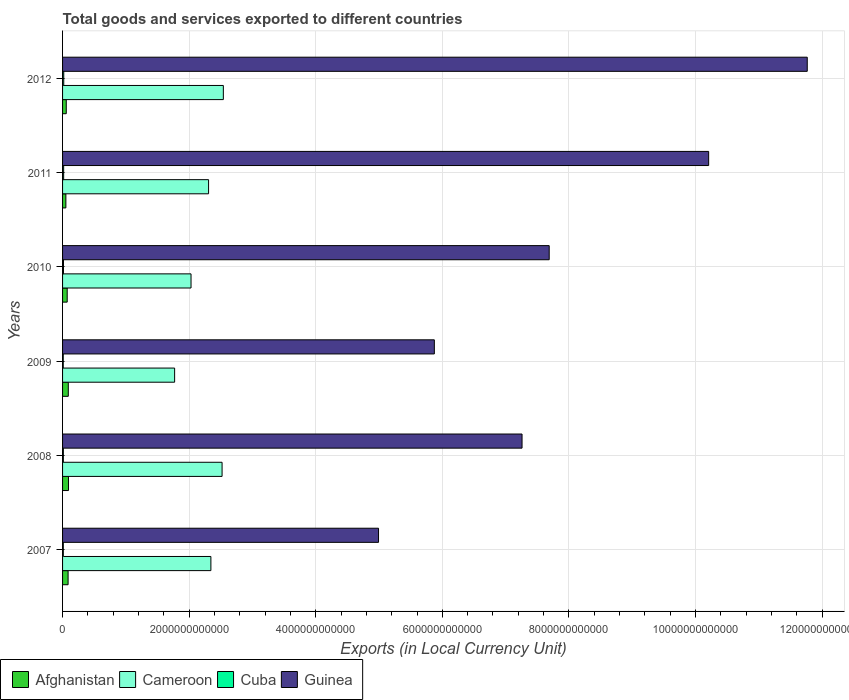How many different coloured bars are there?
Offer a terse response. 4. Are the number of bars per tick equal to the number of legend labels?
Make the answer very short. Yes. How many bars are there on the 1st tick from the bottom?
Your response must be concise. 4. In how many cases, is the number of bars for a given year not equal to the number of legend labels?
Your answer should be compact. 0. What is the Amount of goods and services exports in Cameroon in 2008?
Make the answer very short. 2.52e+12. Across all years, what is the maximum Amount of goods and services exports in Cameroon?
Give a very brief answer. 2.54e+12. Across all years, what is the minimum Amount of goods and services exports in Guinea?
Provide a succinct answer. 4.99e+12. What is the total Amount of goods and services exports in Cuba in the graph?
Ensure brevity in your answer.  8.58e+1. What is the difference between the Amount of goods and services exports in Afghanistan in 2007 and that in 2009?
Your answer should be compact. -3.06e+09. What is the difference between the Amount of goods and services exports in Guinea in 2011 and the Amount of goods and services exports in Afghanistan in 2007?
Provide a short and direct response. 1.01e+13. What is the average Amount of goods and services exports in Cuba per year?
Provide a succinct answer. 1.43e+1. In the year 2011, what is the difference between the Amount of goods and services exports in Cuba and Amount of goods and services exports in Cameroon?
Keep it short and to the point. -2.29e+12. What is the ratio of the Amount of goods and services exports in Afghanistan in 2007 to that in 2008?
Your response must be concise. 0.94. Is the Amount of goods and services exports in Cameroon in 2010 less than that in 2011?
Give a very brief answer. Yes. Is the difference between the Amount of goods and services exports in Cuba in 2010 and 2012 greater than the difference between the Amount of goods and services exports in Cameroon in 2010 and 2012?
Give a very brief answer. Yes. What is the difference between the highest and the second highest Amount of goods and services exports in Cameroon?
Provide a short and direct response. 2.00e+1. What is the difference between the highest and the lowest Amount of goods and services exports in Cameroon?
Offer a very short reply. 7.70e+11. Is it the case that in every year, the sum of the Amount of goods and services exports in Afghanistan and Amount of goods and services exports in Cameroon is greater than the sum of Amount of goods and services exports in Guinea and Amount of goods and services exports in Cuba?
Ensure brevity in your answer.  No. What does the 1st bar from the top in 2007 represents?
Offer a terse response. Guinea. What does the 4th bar from the bottom in 2011 represents?
Your answer should be compact. Guinea. Are all the bars in the graph horizontal?
Give a very brief answer. Yes. How many years are there in the graph?
Give a very brief answer. 6. What is the difference between two consecutive major ticks on the X-axis?
Provide a succinct answer. 2.00e+12. Does the graph contain any zero values?
Your response must be concise. No. Does the graph contain grids?
Ensure brevity in your answer.  Yes. Where does the legend appear in the graph?
Provide a succinct answer. Bottom left. How many legend labels are there?
Make the answer very short. 4. How are the legend labels stacked?
Provide a succinct answer. Horizontal. What is the title of the graph?
Make the answer very short. Total goods and services exported to different countries. What is the label or title of the X-axis?
Your answer should be very brief. Exports (in Local Currency Unit). What is the Exports (in Local Currency Unit) of Afghanistan in 2007?
Offer a very short reply. 8.74e+1. What is the Exports (in Local Currency Unit) in Cameroon in 2007?
Offer a very short reply. 2.34e+12. What is the Exports (in Local Currency Unit) in Cuba in 2007?
Provide a short and direct response. 1.19e+1. What is the Exports (in Local Currency Unit) of Guinea in 2007?
Ensure brevity in your answer.  4.99e+12. What is the Exports (in Local Currency Unit) in Afghanistan in 2008?
Give a very brief answer. 9.34e+1. What is the Exports (in Local Currency Unit) of Cameroon in 2008?
Give a very brief answer. 2.52e+12. What is the Exports (in Local Currency Unit) in Cuba in 2008?
Give a very brief answer. 1.25e+1. What is the Exports (in Local Currency Unit) of Guinea in 2008?
Keep it short and to the point. 7.26e+12. What is the Exports (in Local Currency Unit) in Afghanistan in 2009?
Make the answer very short. 9.05e+1. What is the Exports (in Local Currency Unit) of Cameroon in 2009?
Offer a very short reply. 1.77e+12. What is the Exports (in Local Currency Unit) of Cuba in 2009?
Make the answer very short. 1.08e+1. What is the Exports (in Local Currency Unit) in Guinea in 2009?
Your answer should be compact. 5.87e+12. What is the Exports (in Local Currency Unit) in Afghanistan in 2010?
Your response must be concise. 7.32e+1. What is the Exports (in Local Currency Unit) of Cameroon in 2010?
Offer a terse response. 2.03e+12. What is the Exports (in Local Currency Unit) of Cuba in 2010?
Give a very brief answer. 1.45e+1. What is the Exports (in Local Currency Unit) of Guinea in 2010?
Provide a short and direct response. 7.69e+12. What is the Exports (in Local Currency Unit) of Afghanistan in 2011?
Offer a terse response. 5.23e+1. What is the Exports (in Local Currency Unit) in Cameroon in 2011?
Make the answer very short. 2.31e+12. What is the Exports (in Local Currency Unit) in Cuba in 2011?
Provide a succinct answer. 1.73e+1. What is the Exports (in Local Currency Unit) of Guinea in 2011?
Keep it short and to the point. 1.02e+13. What is the Exports (in Local Currency Unit) in Afghanistan in 2012?
Make the answer very short. 5.86e+1. What is the Exports (in Local Currency Unit) in Cameroon in 2012?
Provide a short and direct response. 2.54e+12. What is the Exports (in Local Currency Unit) in Cuba in 2012?
Keep it short and to the point. 1.87e+1. What is the Exports (in Local Currency Unit) of Guinea in 2012?
Your response must be concise. 1.18e+13. Across all years, what is the maximum Exports (in Local Currency Unit) in Afghanistan?
Keep it short and to the point. 9.34e+1. Across all years, what is the maximum Exports (in Local Currency Unit) of Cameroon?
Give a very brief answer. 2.54e+12. Across all years, what is the maximum Exports (in Local Currency Unit) in Cuba?
Ensure brevity in your answer.  1.87e+1. Across all years, what is the maximum Exports (in Local Currency Unit) in Guinea?
Provide a short and direct response. 1.18e+13. Across all years, what is the minimum Exports (in Local Currency Unit) in Afghanistan?
Your answer should be very brief. 5.23e+1. Across all years, what is the minimum Exports (in Local Currency Unit) of Cameroon?
Keep it short and to the point. 1.77e+12. Across all years, what is the minimum Exports (in Local Currency Unit) in Cuba?
Give a very brief answer. 1.08e+1. Across all years, what is the minimum Exports (in Local Currency Unit) of Guinea?
Offer a terse response. 4.99e+12. What is the total Exports (in Local Currency Unit) of Afghanistan in the graph?
Offer a very short reply. 4.55e+11. What is the total Exports (in Local Currency Unit) in Cameroon in the graph?
Your response must be concise. 1.35e+13. What is the total Exports (in Local Currency Unit) of Cuba in the graph?
Ensure brevity in your answer.  8.58e+1. What is the total Exports (in Local Currency Unit) in Guinea in the graph?
Keep it short and to the point. 4.78e+13. What is the difference between the Exports (in Local Currency Unit) of Afghanistan in 2007 and that in 2008?
Your answer should be very brief. -6.01e+09. What is the difference between the Exports (in Local Currency Unit) of Cameroon in 2007 and that in 2008?
Your response must be concise. -1.77e+11. What is the difference between the Exports (in Local Currency Unit) in Cuba in 2007 and that in 2008?
Make the answer very short. -5.88e+08. What is the difference between the Exports (in Local Currency Unit) in Guinea in 2007 and that in 2008?
Your answer should be compact. -2.27e+12. What is the difference between the Exports (in Local Currency Unit) of Afghanistan in 2007 and that in 2009?
Your answer should be very brief. -3.06e+09. What is the difference between the Exports (in Local Currency Unit) in Cameroon in 2007 and that in 2009?
Provide a succinct answer. 5.73e+11. What is the difference between the Exports (in Local Currency Unit) of Cuba in 2007 and that in 2009?
Offer a very short reply. 1.08e+09. What is the difference between the Exports (in Local Currency Unit) of Guinea in 2007 and that in 2009?
Offer a very short reply. -8.82e+11. What is the difference between the Exports (in Local Currency Unit) of Afghanistan in 2007 and that in 2010?
Give a very brief answer. 1.42e+1. What is the difference between the Exports (in Local Currency Unit) in Cameroon in 2007 and that in 2010?
Ensure brevity in your answer.  3.14e+11. What is the difference between the Exports (in Local Currency Unit) in Cuba in 2007 and that in 2010?
Offer a terse response. -2.60e+09. What is the difference between the Exports (in Local Currency Unit) in Guinea in 2007 and that in 2010?
Offer a very short reply. -2.70e+12. What is the difference between the Exports (in Local Currency Unit) in Afghanistan in 2007 and that in 2011?
Your response must be concise. 3.51e+1. What is the difference between the Exports (in Local Currency Unit) of Cameroon in 2007 and that in 2011?
Your answer should be compact. 3.65e+1. What is the difference between the Exports (in Local Currency Unit) of Cuba in 2007 and that in 2011?
Provide a short and direct response. -5.40e+09. What is the difference between the Exports (in Local Currency Unit) of Guinea in 2007 and that in 2011?
Offer a very short reply. -5.22e+12. What is the difference between the Exports (in Local Currency Unit) in Afghanistan in 2007 and that in 2012?
Make the answer very short. 2.89e+1. What is the difference between the Exports (in Local Currency Unit) of Cameroon in 2007 and that in 2012?
Your response must be concise. -1.97e+11. What is the difference between the Exports (in Local Currency Unit) of Cuba in 2007 and that in 2012?
Your answer should be very brief. -6.74e+09. What is the difference between the Exports (in Local Currency Unit) in Guinea in 2007 and that in 2012?
Offer a very short reply. -6.77e+12. What is the difference between the Exports (in Local Currency Unit) of Afghanistan in 2008 and that in 2009?
Offer a very short reply. 2.95e+09. What is the difference between the Exports (in Local Currency Unit) of Cameroon in 2008 and that in 2009?
Offer a terse response. 7.50e+11. What is the difference between the Exports (in Local Currency Unit) in Cuba in 2008 and that in 2009?
Ensure brevity in your answer.  1.67e+09. What is the difference between the Exports (in Local Currency Unit) of Guinea in 2008 and that in 2009?
Keep it short and to the point. 1.39e+12. What is the difference between the Exports (in Local Currency Unit) of Afghanistan in 2008 and that in 2010?
Provide a succinct answer. 2.03e+1. What is the difference between the Exports (in Local Currency Unit) of Cameroon in 2008 and that in 2010?
Offer a terse response. 4.91e+11. What is the difference between the Exports (in Local Currency Unit) of Cuba in 2008 and that in 2010?
Provide a succinct answer. -2.01e+09. What is the difference between the Exports (in Local Currency Unit) in Guinea in 2008 and that in 2010?
Ensure brevity in your answer.  -4.29e+11. What is the difference between the Exports (in Local Currency Unit) of Afghanistan in 2008 and that in 2011?
Make the answer very short. 4.11e+1. What is the difference between the Exports (in Local Currency Unit) in Cameroon in 2008 and that in 2011?
Keep it short and to the point. 2.13e+11. What is the difference between the Exports (in Local Currency Unit) in Cuba in 2008 and that in 2011?
Make the answer very short. -4.81e+09. What is the difference between the Exports (in Local Currency Unit) of Guinea in 2008 and that in 2011?
Your answer should be very brief. -2.95e+12. What is the difference between the Exports (in Local Currency Unit) of Afghanistan in 2008 and that in 2012?
Your response must be concise. 3.49e+1. What is the difference between the Exports (in Local Currency Unit) in Cameroon in 2008 and that in 2012?
Ensure brevity in your answer.  -2.00e+1. What is the difference between the Exports (in Local Currency Unit) in Cuba in 2008 and that in 2012?
Provide a succinct answer. -6.15e+09. What is the difference between the Exports (in Local Currency Unit) in Guinea in 2008 and that in 2012?
Your answer should be compact. -4.51e+12. What is the difference between the Exports (in Local Currency Unit) in Afghanistan in 2009 and that in 2010?
Provide a short and direct response. 1.73e+1. What is the difference between the Exports (in Local Currency Unit) of Cameroon in 2009 and that in 2010?
Ensure brevity in your answer.  -2.59e+11. What is the difference between the Exports (in Local Currency Unit) in Cuba in 2009 and that in 2010?
Offer a very short reply. -3.68e+09. What is the difference between the Exports (in Local Currency Unit) in Guinea in 2009 and that in 2010?
Offer a terse response. -1.81e+12. What is the difference between the Exports (in Local Currency Unit) of Afghanistan in 2009 and that in 2011?
Your answer should be compact. 3.82e+1. What is the difference between the Exports (in Local Currency Unit) in Cameroon in 2009 and that in 2011?
Give a very brief answer. -5.36e+11. What is the difference between the Exports (in Local Currency Unit) of Cuba in 2009 and that in 2011?
Keep it short and to the point. -6.48e+09. What is the difference between the Exports (in Local Currency Unit) in Guinea in 2009 and that in 2011?
Offer a very short reply. -4.33e+12. What is the difference between the Exports (in Local Currency Unit) of Afghanistan in 2009 and that in 2012?
Provide a succinct answer. 3.19e+1. What is the difference between the Exports (in Local Currency Unit) in Cameroon in 2009 and that in 2012?
Keep it short and to the point. -7.70e+11. What is the difference between the Exports (in Local Currency Unit) in Cuba in 2009 and that in 2012?
Your answer should be very brief. -7.82e+09. What is the difference between the Exports (in Local Currency Unit) in Guinea in 2009 and that in 2012?
Ensure brevity in your answer.  -5.89e+12. What is the difference between the Exports (in Local Currency Unit) in Afghanistan in 2010 and that in 2011?
Provide a succinct answer. 2.09e+1. What is the difference between the Exports (in Local Currency Unit) in Cameroon in 2010 and that in 2011?
Give a very brief answer. -2.77e+11. What is the difference between the Exports (in Local Currency Unit) in Cuba in 2010 and that in 2011?
Your answer should be very brief. -2.80e+09. What is the difference between the Exports (in Local Currency Unit) in Guinea in 2010 and that in 2011?
Your response must be concise. -2.52e+12. What is the difference between the Exports (in Local Currency Unit) of Afghanistan in 2010 and that in 2012?
Make the answer very short. 1.46e+1. What is the difference between the Exports (in Local Currency Unit) in Cameroon in 2010 and that in 2012?
Make the answer very short. -5.11e+11. What is the difference between the Exports (in Local Currency Unit) in Cuba in 2010 and that in 2012?
Offer a very short reply. -4.14e+09. What is the difference between the Exports (in Local Currency Unit) in Guinea in 2010 and that in 2012?
Ensure brevity in your answer.  -4.08e+12. What is the difference between the Exports (in Local Currency Unit) in Afghanistan in 2011 and that in 2012?
Your response must be concise. -6.25e+09. What is the difference between the Exports (in Local Currency Unit) in Cameroon in 2011 and that in 2012?
Your answer should be very brief. -2.33e+11. What is the difference between the Exports (in Local Currency Unit) of Cuba in 2011 and that in 2012?
Make the answer very short. -1.34e+09. What is the difference between the Exports (in Local Currency Unit) of Guinea in 2011 and that in 2012?
Keep it short and to the point. -1.56e+12. What is the difference between the Exports (in Local Currency Unit) of Afghanistan in 2007 and the Exports (in Local Currency Unit) of Cameroon in 2008?
Make the answer very short. -2.43e+12. What is the difference between the Exports (in Local Currency Unit) in Afghanistan in 2007 and the Exports (in Local Currency Unit) in Cuba in 2008?
Offer a very short reply. 7.49e+1. What is the difference between the Exports (in Local Currency Unit) in Afghanistan in 2007 and the Exports (in Local Currency Unit) in Guinea in 2008?
Make the answer very short. -7.17e+12. What is the difference between the Exports (in Local Currency Unit) of Cameroon in 2007 and the Exports (in Local Currency Unit) of Cuba in 2008?
Offer a terse response. 2.33e+12. What is the difference between the Exports (in Local Currency Unit) in Cameroon in 2007 and the Exports (in Local Currency Unit) in Guinea in 2008?
Your answer should be compact. -4.92e+12. What is the difference between the Exports (in Local Currency Unit) of Cuba in 2007 and the Exports (in Local Currency Unit) of Guinea in 2008?
Your response must be concise. -7.25e+12. What is the difference between the Exports (in Local Currency Unit) in Afghanistan in 2007 and the Exports (in Local Currency Unit) in Cameroon in 2009?
Make the answer very short. -1.68e+12. What is the difference between the Exports (in Local Currency Unit) in Afghanistan in 2007 and the Exports (in Local Currency Unit) in Cuba in 2009?
Keep it short and to the point. 7.66e+1. What is the difference between the Exports (in Local Currency Unit) in Afghanistan in 2007 and the Exports (in Local Currency Unit) in Guinea in 2009?
Offer a terse response. -5.79e+12. What is the difference between the Exports (in Local Currency Unit) of Cameroon in 2007 and the Exports (in Local Currency Unit) of Cuba in 2009?
Your answer should be very brief. 2.33e+12. What is the difference between the Exports (in Local Currency Unit) in Cameroon in 2007 and the Exports (in Local Currency Unit) in Guinea in 2009?
Make the answer very short. -3.53e+12. What is the difference between the Exports (in Local Currency Unit) of Cuba in 2007 and the Exports (in Local Currency Unit) of Guinea in 2009?
Make the answer very short. -5.86e+12. What is the difference between the Exports (in Local Currency Unit) of Afghanistan in 2007 and the Exports (in Local Currency Unit) of Cameroon in 2010?
Give a very brief answer. -1.94e+12. What is the difference between the Exports (in Local Currency Unit) of Afghanistan in 2007 and the Exports (in Local Currency Unit) of Cuba in 2010?
Your answer should be very brief. 7.29e+1. What is the difference between the Exports (in Local Currency Unit) of Afghanistan in 2007 and the Exports (in Local Currency Unit) of Guinea in 2010?
Offer a very short reply. -7.60e+12. What is the difference between the Exports (in Local Currency Unit) of Cameroon in 2007 and the Exports (in Local Currency Unit) of Cuba in 2010?
Offer a very short reply. 2.33e+12. What is the difference between the Exports (in Local Currency Unit) in Cameroon in 2007 and the Exports (in Local Currency Unit) in Guinea in 2010?
Provide a succinct answer. -5.34e+12. What is the difference between the Exports (in Local Currency Unit) of Cuba in 2007 and the Exports (in Local Currency Unit) of Guinea in 2010?
Give a very brief answer. -7.68e+12. What is the difference between the Exports (in Local Currency Unit) of Afghanistan in 2007 and the Exports (in Local Currency Unit) of Cameroon in 2011?
Your answer should be compact. -2.22e+12. What is the difference between the Exports (in Local Currency Unit) in Afghanistan in 2007 and the Exports (in Local Currency Unit) in Cuba in 2011?
Your answer should be compact. 7.01e+1. What is the difference between the Exports (in Local Currency Unit) in Afghanistan in 2007 and the Exports (in Local Currency Unit) in Guinea in 2011?
Your answer should be compact. -1.01e+13. What is the difference between the Exports (in Local Currency Unit) in Cameroon in 2007 and the Exports (in Local Currency Unit) in Cuba in 2011?
Provide a short and direct response. 2.33e+12. What is the difference between the Exports (in Local Currency Unit) in Cameroon in 2007 and the Exports (in Local Currency Unit) in Guinea in 2011?
Offer a very short reply. -7.86e+12. What is the difference between the Exports (in Local Currency Unit) in Cuba in 2007 and the Exports (in Local Currency Unit) in Guinea in 2011?
Make the answer very short. -1.02e+13. What is the difference between the Exports (in Local Currency Unit) in Afghanistan in 2007 and the Exports (in Local Currency Unit) in Cameroon in 2012?
Provide a succinct answer. -2.45e+12. What is the difference between the Exports (in Local Currency Unit) of Afghanistan in 2007 and the Exports (in Local Currency Unit) of Cuba in 2012?
Provide a succinct answer. 6.87e+1. What is the difference between the Exports (in Local Currency Unit) of Afghanistan in 2007 and the Exports (in Local Currency Unit) of Guinea in 2012?
Your answer should be very brief. -1.17e+13. What is the difference between the Exports (in Local Currency Unit) of Cameroon in 2007 and the Exports (in Local Currency Unit) of Cuba in 2012?
Provide a succinct answer. 2.32e+12. What is the difference between the Exports (in Local Currency Unit) of Cameroon in 2007 and the Exports (in Local Currency Unit) of Guinea in 2012?
Your response must be concise. -9.42e+12. What is the difference between the Exports (in Local Currency Unit) of Cuba in 2007 and the Exports (in Local Currency Unit) of Guinea in 2012?
Your response must be concise. -1.18e+13. What is the difference between the Exports (in Local Currency Unit) in Afghanistan in 2008 and the Exports (in Local Currency Unit) in Cameroon in 2009?
Give a very brief answer. -1.68e+12. What is the difference between the Exports (in Local Currency Unit) in Afghanistan in 2008 and the Exports (in Local Currency Unit) in Cuba in 2009?
Keep it short and to the point. 8.26e+1. What is the difference between the Exports (in Local Currency Unit) in Afghanistan in 2008 and the Exports (in Local Currency Unit) in Guinea in 2009?
Make the answer very short. -5.78e+12. What is the difference between the Exports (in Local Currency Unit) of Cameroon in 2008 and the Exports (in Local Currency Unit) of Cuba in 2009?
Your answer should be compact. 2.51e+12. What is the difference between the Exports (in Local Currency Unit) of Cameroon in 2008 and the Exports (in Local Currency Unit) of Guinea in 2009?
Keep it short and to the point. -3.35e+12. What is the difference between the Exports (in Local Currency Unit) of Cuba in 2008 and the Exports (in Local Currency Unit) of Guinea in 2009?
Give a very brief answer. -5.86e+12. What is the difference between the Exports (in Local Currency Unit) in Afghanistan in 2008 and the Exports (in Local Currency Unit) in Cameroon in 2010?
Ensure brevity in your answer.  -1.94e+12. What is the difference between the Exports (in Local Currency Unit) in Afghanistan in 2008 and the Exports (in Local Currency Unit) in Cuba in 2010?
Your response must be concise. 7.89e+1. What is the difference between the Exports (in Local Currency Unit) in Afghanistan in 2008 and the Exports (in Local Currency Unit) in Guinea in 2010?
Your answer should be very brief. -7.59e+12. What is the difference between the Exports (in Local Currency Unit) in Cameroon in 2008 and the Exports (in Local Currency Unit) in Cuba in 2010?
Give a very brief answer. 2.51e+12. What is the difference between the Exports (in Local Currency Unit) of Cameroon in 2008 and the Exports (in Local Currency Unit) of Guinea in 2010?
Provide a short and direct response. -5.17e+12. What is the difference between the Exports (in Local Currency Unit) in Cuba in 2008 and the Exports (in Local Currency Unit) in Guinea in 2010?
Your answer should be compact. -7.68e+12. What is the difference between the Exports (in Local Currency Unit) of Afghanistan in 2008 and the Exports (in Local Currency Unit) of Cameroon in 2011?
Make the answer very short. -2.21e+12. What is the difference between the Exports (in Local Currency Unit) in Afghanistan in 2008 and the Exports (in Local Currency Unit) in Cuba in 2011?
Make the answer very short. 7.61e+1. What is the difference between the Exports (in Local Currency Unit) in Afghanistan in 2008 and the Exports (in Local Currency Unit) in Guinea in 2011?
Ensure brevity in your answer.  -1.01e+13. What is the difference between the Exports (in Local Currency Unit) in Cameroon in 2008 and the Exports (in Local Currency Unit) in Cuba in 2011?
Ensure brevity in your answer.  2.50e+12. What is the difference between the Exports (in Local Currency Unit) of Cameroon in 2008 and the Exports (in Local Currency Unit) of Guinea in 2011?
Provide a succinct answer. -7.69e+12. What is the difference between the Exports (in Local Currency Unit) of Cuba in 2008 and the Exports (in Local Currency Unit) of Guinea in 2011?
Your response must be concise. -1.02e+13. What is the difference between the Exports (in Local Currency Unit) in Afghanistan in 2008 and the Exports (in Local Currency Unit) in Cameroon in 2012?
Offer a terse response. -2.45e+12. What is the difference between the Exports (in Local Currency Unit) in Afghanistan in 2008 and the Exports (in Local Currency Unit) in Cuba in 2012?
Offer a very short reply. 7.48e+1. What is the difference between the Exports (in Local Currency Unit) of Afghanistan in 2008 and the Exports (in Local Currency Unit) of Guinea in 2012?
Provide a short and direct response. -1.17e+13. What is the difference between the Exports (in Local Currency Unit) of Cameroon in 2008 and the Exports (in Local Currency Unit) of Cuba in 2012?
Make the answer very short. 2.50e+12. What is the difference between the Exports (in Local Currency Unit) of Cameroon in 2008 and the Exports (in Local Currency Unit) of Guinea in 2012?
Your answer should be very brief. -9.24e+12. What is the difference between the Exports (in Local Currency Unit) in Cuba in 2008 and the Exports (in Local Currency Unit) in Guinea in 2012?
Give a very brief answer. -1.18e+13. What is the difference between the Exports (in Local Currency Unit) in Afghanistan in 2009 and the Exports (in Local Currency Unit) in Cameroon in 2010?
Your answer should be compact. -1.94e+12. What is the difference between the Exports (in Local Currency Unit) of Afghanistan in 2009 and the Exports (in Local Currency Unit) of Cuba in 2010?
Your answer should be compact. 7.59e+1. What is the difference between the Exports (in Local Currency Unit) in Afghanistan in 2009 and the Exports (in Local Currency Unit) in Guinea in 2010?
Provide a succinct answer. -7.60e+12. What is the difference between the Exports (in Local Currency Unit) of Cameroon in 2009 and the Exports (in Local Currency Unit) of Cuba in 2010?
Provide a short and direct response. 1.76e+12. What is the difference between the Exports (in Local Currency Unit) of Cameroon in 2009 and the Exports (in Local Currency Unit) of Guinea in 2010?
Make the answer very short. -5.92e+12. What is the difference between the Exports (in Local Currency Unit) of Cuba in 2009 and the Exports (in Local Currency Unit) of Guinea in 2010?
Offer a terse response. -7.68e+12. What is the difference between the Exports (in Local Currency Unit) in Afghanistan in 2009 and the Exports (in Local Currency Unit) in Cameroon in 2011?
Give a very brief answer. -2.22e+12. What is the difference between the Exports (in Local Currency Unit) in Afghanistan in 2009 and the Exports (in Local Currency Unit) in Cuba in 2011?
Ensure brevity in your answer.  7.31e+1. What is the difference between the Exports (in Local Currency Unit) in Afghanistan in 2009 and the Exports (in Local Currency Unit) in Guinea in 2011?
Give a very brief answer. -1.01e+13. What is the difference between the Exports (in Local Currency Unit) in Cameroon in 2009 and the Exports (in Local Currency Unit) in Cuba in 2011?
Your answer should be compact. 1.75e+12. What is the difference between the Exports (in Local Currency Unit) of Cameroon in 2009 and the Exports (in Local Currency Unit) of Guinea in 2011?
Give a very brief answer. -8.44e+12. What is the difference between the Exports (in Local Currency Unit) of Cuba in 2009 and the Exports (in Local Currency Unit) of Guinea in 2011?
Your answer should be very brief. -1.02e+13. What is the difference between the Exports (in Local Currency Unit) of Afghanistan in 2009 and the Exports (in Local Currency Unit) of Cameroon in 2012?
Offer a very short reply. -2.45e+12. What is the difference between the Exports (in Local Currency Unit) in Afghanistan in 2009 and the Exports (in Local Currency Unit) in Cuba in 2012?
Your response must be concise. 7.18e+1. What is the difference between the Exports (in Local Currency Unit) in Afghanistan in 2009 and the Exports (in Local Currency Unit) in Guinea in 2012?
Offer a terse response. -1.17e+13. What is the difference between the Exports (in Local Currency Unit) of Cameroon in 2009 and the Exports (in Local Currency Unit) of Cuba in 2012?
Offer a terse response. 1.75e+12. What is the difference between the Exports (in Local Currency Unit) of Cameroon in 2009 and the Exports (in Local Currency Unit) of Guinea in 2012?
Your answer should be compact. -9.99e+12. What is the difference between the Exports (in Local Currency Unit) in Cuba in 2009 and the Exports (in Local Currency Unit) in Guinea in 2012?
Your answer should be compact. -1.18e+13. What is the difference between the Exports (in Local Currency Unit) of Afghanistan in 2010 and the Exports (in Local Currency Unit) of Cameroon in 2011?
Provide a succinct answer. -2.23e+12. What is the difference between the Exports (in Local Currency Unit) in Afghanistan in 2010 and the Exports (in Local Currency Unit) in Cuba in 2011?
Make the answer very short. 5.58e+1. What is the difference between the Exports (in Local Currency Unit) in Afghanistan in 2010 and the Exports (in Local Currency Unit) in Guinea in 2011?
Ensure brevity in your answer.  -1.01e+13. What is the difference between the Exports (in Local Currency Unit) of Cameroon in 2010 and the Exports (in Local Currency Unit) of Cuba in 2011?
Make the answer very short. 2.01e+12. What is the difference between the Exports (in Local Currency Unit) of Cameroon in 2010 and the Exports (in Local Currency Unit) of Guinea in 2011?
Ensure brevity in your answer.  -8.18e+12. What is the difference between the Exports (in Local Currency Unit) in Cuba in 2010 and the Exports (in Local Currency Unit) in Guinea in 2011?
Give a very brief answer. -1.02e+13. What is the difference between the Exports (in Local Currency Unit) of Afghanistan in 2010 and the Exports (in Local Currency Unit) of Cameroon in 2012?
Your answer should be very brief. -2.47e+12. What is the difference between the Exports (in Local Currency Unit) of Afghanistan in 2010 and the Exports (in Local Currency Unit) of Cuba in 2012?
Keep it short and to the point. 5.45e+1. What is the difference between the Exports (in Local Currency Unit) of Afghanistan in 2010 and the Exports (in Local Currency Unit) of Guinea in 2012?
Give a very brief answer. -1.17e+13. What is the difference between the Exports (in Local Currency Unit) in Cameroon in 2010 and the Exports (in Local Currency Unit) in Cuba in 2012?
Give a very brief answer. 2.01e+12. What is the difference between the Exports (in Local Currency Unit) in Cameroon in 2010 and the Exports (in Local Currency Unit) in Guinea in 2012?
Make the answer very short. -9.74e+12. What is the difference between the Exports (in Local Currency Unit) of Cuba in 2010 and the Exports (in Local Currency Unit) of Guinea in 2012?
Your answer should be very brief. -1.18e+13. What is the difference between the Exports (in Local Currency Unit) of Afghanistan in 2011 and the Exports (in Local Currency Unit) of Cameroon in 2012?
Provide a short and direct response. -2.49e+12. What is the difference between the Exports (in Local Currency Unit) in Afghanistan in 2011 and the Exports (in Local Currency Unit) in Cuba in 2012?
Ensure brevity in your answer.  3.36e+1. What is the difference between the Exports (in Local Currency Unit) in Afghanistan in 2011 and the Exports (in Local Currency Unit) in Guinea in 2012?
Your answer should be very brief. -1.17e+13. What is the difference between the Exports (in Local Currency Unit) in Cameroon in 2011 and the Exports (in Local Currency Unit) in Cuba in 2012?
Provide a succinct answer. 2.29e+12. What is the difference between the Exports (in Local Currency Unit) of Cameroon in 2011 and the Exports (in Local Currency Unit) of Guinea in 2012?
Provide a short and direct response. -9.46e+12. What is the difference between the Exports (in Local Currency Unit) of Cuba in 2011 and the Exports (in Local Currency Unit) of Guinea in 2012?
Offer a very short reply. -1.17e+13. What is the average Exports (in Local Currency Unit) in Afghanistan per year?
Ensure brevity in your answer.  7.59e+1. What is the average Exports (in Local Currency Unit) of Cameroon per year?
Your answer should be compact. 2.25e+12. What is the average Exports (in Local Currency Unit) in Cuba per year?
Give a very brief answer. 1.43e+1. What is the average Exports (in Local Currency Unit) of Guinea per year?
Keep it short and to the point. 7.96e+12. In the year 2007, what is the difference between the Exports (in Local Currency Unit) of Afghanistan and Exports (in Local Currency Unit) of Cameroon?
Ensure brevity in your answer.  -2.26e+12. In the year 2007, what is the difference between the Exports (in Local Currency Unit) in Afghanistan and Exports (in Local Currency Unit) in Cuba?
Ensure brevity in your answer.  7.55e+1. In the year 2007, what is the difference between the Exports (in Local Currency Unit) of Afghanistan and Exports (in Local Currency Unit) of Guinea?
Ensure brevity in your answer.  -4.90e+12. In the year 2007, what is the difference between the Exports (in Local Currency Unit) in Cameroon and Exports (in Local Currency Unit) in Cuba?
Ensure brevity in your answer.  2.33e+12. In the year 2007, what is the difference between the Exports (in Local Currency Unit) of Cameroon and Exports (in Local Currency Unit) of Guinea?
Keep it short and to the point. -2.65e+12. In the year 2007, what is the difference between the Exports (in Local Currency Unit) of Cuba and Exports (in Local Currency Unit) of Guinea?
Offer a terse response. -4.98e+12. In the year 2008, what is the difference between the Exports (in Local Currency Unit) of Afghanistan and Exports (in Local Currency Unit) of Cameroon?
Ensure brevity in your answer.  -2.43e+12. In the year 2008, what is the difference between the Exports (in Local Currency Unit) in Afghanistan and Exports (in Local Currency Unit) in Cuba?
Your response must be concise. 8.09e+1. In the year 2008, what is the difference between the Exports (in Local Currency Unit) in Afghanistan and Exports (in Local Currency Unit) in Guinea?
Your answer should be compact. -7.17e+12. In the year 2008, what is the difference between the Exports (in Local Currency Unit) in Cameroon and Exports (in Local Currency Unit) in Cuba?
Ensure brevity in your answer.  2.51e+12. In the year 2008, what is the difference between the Exports (in Local Currency Unit) in Cameroon and Exports (in Local Currency Unit) in Guinea?
Offer a terse response. -4.74e+12. In the year 2008, what is the difference between the Exports (in Local Currency Unit) in Cuba and Exports (in Local Currency Unit) in Guinea?
Offer a very short reply. -7.25e+12. In the year 2009, what is the difference between the Exports (in Local Currency Unit) of Afghanistan and Exports (in Local Currency Unit) of Cameroon?
Provide a succinct answer. -1.68e+12. In the year 2009, what is the difference between the Exports (in Local Currency Unit) of Afghanistan and Exports (in Local Currency Unit) of Cuba?
Offer a very short reply. 7.96e+1. In the year 2009, what is the difference between the Exports (in Local Currency Unit) of Afghanistan and Exports (in Local Currency Unit) of Guinea?
Make the answer very short. -5.78e+12. In the year 2009, what is the difference between the Exports (in Local Currency Unit) in Cameroon and Exports (in Local Currency Unit) in Cuba?
Ensure brevity in your answer.  1.76e+12. In the year 2009, what is the difference between the Exports (in Local Currency Unit) of Cameroon and Exports (in Local Currency Unit) of Guinea?
Offer a terse response. -4.10e+12. In the year 2009, what is the difference between the Exports (in Local Currency Unit) in Cuba and Exports (in Local Currency Unit) in Guinea?
Make the answer very short. -5.86e+12. In the year 2010, what is the difference between the Exports (in Local Currency Unit) in Afghanistan and Exports (in Local Currency Unit) in Cameroon?
Your answer should be very brief. -1.96e+12. In the year 2010, what is the difference between the Exports (in Local Currency Unit) in Afghanistan and Exports (in Local Currency Unit) in Cuba?
Give a very brief answer. 5.86e+1. In the year 2010, what is the difference between the Exports (in Local Currency Unit) in Afghanistan and Exports (in Local Currency Unit) in Guinea?
Your answer should be compact. -7.61e+12. In the year 2010, what is the difference between the Exports (in Local Currency Unit) of Cameroon and Exports (in Local Currency Unit) of Cuba?
Make the answer very short. 2.02e+12. In the year 2010, what is the difference between the Exports (in Local Currency Unit) in Cameroon and Exports (in Local Currency Unit) in Guinea?
Ensure brevity in your answer.  -5.66e+12. In the year 2010, what is the difference between the Exports (in Local Currency Unit) in Cuba and Exports (in Local Currency Unit) in Guinea?
Make the answer very short. -7.67e+12. In the year 2011, what is the difference between the Exports (in Local Currency Unit) in Afghanistan and Exports (in Local Currency Unit) in Cameroon?
Offer a terse response. -2.25e+12. In the year 2011, what is the difference between the Exports (in Local Currency Unit) of Afghanistan and Exports (in Local Currency Unit) of Cuba?
Your answer should be compact. 3.50e+1. In the year 2011, what is the difference between the Exports (in Local Currency Unit) in Afghanistan and Exports (in Local Currency Unit) in Guinea?
Ensure brevity in your answer.  -1.02e+13. In the year 2011, what is the difference between the Exports (in Local Currency Unit) in Cameroon and Exports (in Local Currency Unit) in Cuba?
Your response must be concise. 2.29e+12. In the year 2011, what is the difference between the Exports (in Local Currency Unit) in Cameroon and Exports (in Local Currency Unit) in Guinea?
Offer a terse response. -7.90e+12. In the year 2011, what is the difference between the Exports (in Local Currency Unit) of Cuba and Exports (in Local Currency Unit) of Guinea?
Keep it short and to the point. -1.02e+13. In the year 2012, what is the difference between the Exports (in Local Currency Unit) in Afghanistan and Exports (in Local Currency Unit) in Cameroon?
Offer a terse response. -2.48e+12. In the year 2012, what is the difference between the Exports (in Local Currency Unit) of Afghanistan and Exports (in Local Currency Unit) of Cuba?
Make the answer very short. 3.99e+1. In the year 2012, what is the difference between the Exports (in Local Currency Unit) of Afghanistan and Exports (in Local Currency Unit) of Guinea?
Keep it short and to the point. -1.17e+13. In the year 2012, what is the difference between the Exports (in Local Currency Unit) of Cameroon and Exports (in Local Currency Unit) of Cuba?
Your response must be concise. 2.52e+12. In the year 2012, what is the difference between the Exports (in Local Currency Unit) in Cameroon and Exports (in Local Currency Unit) in Guinea?
Keep it short and to the point. -9.22e+12. In the year 2012, what is the difference between the Exports (in Local Currency Unit) of Cuba and Exports (in Local Currency Unit) of Guinea?
Offer a very short reply. -1.17e+13. What is the ratio of the Exports (in Local Currency Unit) of Afghanistan in 2007 to that in 2008?
Offer a very short reply. 0.94. What is the ratio of the Exports (in Local Currency Unit) of Cameroon in 2007 to that in 2008?
Your answer should be very brief. 0.93. What is the ratio of the Exports (in Local Currency Unit) in Cuba in 2007 to that in 2008?
Ensure brevity in your answer.  0.95. What is the ratio of the Exports (in Local Currency Unit) in Guinea in 2007 to that in 2008?
Your answer should be very brief. 0.69. What is the ratio of the Exports (in Local Currency Unit) in Afghanistan in 2007 to that in 2009?
Offer a terse response. 0.97. What is the ratio of the Exports (in Local Currency Unit) of Cameroon in 2007 to that in 2009?
Provide a short and direct response. 1.32. What is the ratio of the Exports (in Local Currency Unit) in Cuba in 2007 to that in 2009?
Give a very brief answer. 1.1. What is the ratio of the Exports (in Local Currency Unit) in Guinea in 2007 to that in 2009?
Offer a terse response. 0.85. What is the ratio of the Exports (in Local Currency Unit) in Afghanistan in 2007 to that in 2010?
Your answer should be compact. 1.19. What is the ratio of the Exports (in Local Currency Unit) of Cameroon in 2007 to that in 2010?
Offer a very short reply. 1.15. What is the ratio of the Exports (in Local Currency Unit) of Cuba in 2007 to that in 2010?
Keep it short and to the point. 0.82. What is the ratio of the Exports (in Local Currency Unit) in Guinea in 2007 to that in 2010?
Offer a terse response. 0.65. What is the ratio of the Exports (in Local Currency Unit) of Afghanistan in 2007 to that in 2011?
Your response must be concise. 1.67. What is the ratio of the Exports (in Local Currency Unit) of Cameroon in 2007 to that in 2011?
Ensure brevity in your answer.  1.02. What is the ratio of the Exports (in Local Currency Unit) of Cuba in 2007 to that in 2011?
Your response must be concise. 0.69. What is the ratio of the Exports (in Local Currency Unit) of Guinea in 2007 to that in 2011?
Ensure brevity in your answer.  0.49. What is the ratio of the Exports (in Local Currency Unit) of Afghanistan in 2007 to that in 2012?
Your answer should be very brief. 1.49. What is the ratio of the Exports (in Local Currency Unit) of Cameroon in 2007 to that in 2012?
Give a very brief answer. 0.92. What is the ratio of the Exports (in Local Currency Unit) of Cuba in 2007 to that in 2012?
Your response must be concise. 0.64. What is the ratio of the Exports (in Local Currency Unit) in Guinea in 2007 to that in 2012?
Provide a succinct answer. 0.42. What is the ratio of the Exports (in Local Currency Unit) of Afghanistan in 2008 to that in 2009?
Ensure brevity in your answer.  1.03. What is the ratio of the Exports (in Local Currency Unit) of Cameroon in 2008 to that in 2009?
Your answer should be compact. 1.42. What is the ratio of the Exports (in Local Currency Unit) of Cuba in 2008 to that in 2009?
Offer a very short reply. 1.15. What is the ratio of the Exports (in Local Currency Unit) of Guinea in 2008 to that in 2009?
Your answer should be very brief. 1.24. What is the ratio of the Exports (in Local Currency Unit) of Afghanistan in 2008 to that in 2010?
Keep it short and to the point. 1.28. What is the ratio of the Exports (in Local Currency Unit) in Cameroon in 2008 to that in 2010?
Your answer should be very brief. 1.24. What is the ratio of the Exports (in Local Currency Unit) of Cuba in 2008 to that in 2010?
Make the answer very short. 0.86. What is the ratio of the Exports (in Local Currency Unit) of Guinea in 2008 to that in 2010?
Give a very brief answer. 0.94. What is the ratio of the Exports (in Local Currency Unit) in Afghanistan in 2008 to that in 2011?
Provide a short and direct response. 1.79. What is the ratio of the Exports (in Local Currency Unit) in Cameroon in 2008 to that in 2011?
Offer a terse response. 1.09. What is the ratio of the Exports (in Local Currency Unit) of Cuba in 2008 to that in 2011?
Your answer should be very brief. 0.72. What is the ratio of the Exports (in Local Currency Unit) in Guinea in 2008 to that in 2011?
Your answer should be very brief. 0.71. What is the ratio of the Exports (in Local Currency Unit) in Afghanistan in 2008 to that in 2012?
Offer a very short reply. 1.6. What is the ratio of the Exports (in Local Currency Unit) of Cuba in 2008 to that in 2012?
Ensure brevity in your answer.  0.67. What is the ratio of the Exports (in Local Currency Unit) in Guinea in 2008 to that in 2012?
Your answer should be compact. 0.62. What is the ratio of the Exports (in Local Currency Unit) of Afghanistan in 2009 to that in 2010?
Your response must be concise. 1.24. What is the ratio of the Exports (in Local Currency Unit) of Cameroon in 2009 to that in 2010?
Provide a succinct answer. 0.87. What is the ratio of the Exports (in Local Currency Unit) of Cuba in 2009 to that in 2010?
Your answer should be very brief. 0.75. What is the ratio of the Exports (in Local Currency Unit) in Guinea in 2009 to that in 2010?
Offer a very short reply. 0.76. What is the ratio of the Exports (in Local Currency Unit) of Afghanistan in 2009 to that in 2011?
Ensure brevity in your answer.  1.73. What is the ratio of the Exports (in Local Currency Unit) of Cameroon in 2009 to that in 2011?
Provide a short and direct response. 0.77. What is the ratio of the Exports (in Local Currency Unit) in Cuba in 2009 to that in 2011?
Ensure brevity in your answer.  0.63. What is the ratio of the Exports (in Local Currency Unit) in Guinea in 2009 to that in 2011?
Offer a terse response. 0.58. What is the ratio of the Exports (in Local Currency Unit) in Afghanistan in 2009 to that in 2012?
Provide a succinct answer. 1.54. What is the ratio of the Exports (in Local Currency Unit) of Cameroon in 2009 to that in 2012?
Keep it short and to the point. 0.7. What is the ratio of the Exports (in Local Currency Unit) of Cuba in 2009 to that in 2012?
Offer a terse response. 0.58. What is the ratio of the Exports (in Local Currency Unit) of Guinea in 2009 to that in 2012?
Your answer should be compact. 0.5. What is the ratio of the Exports (in Local Currency Unit) in Afghanistan in 2010 to that in 2011?
Make the answer very short. 1.4. What is the ratio of the Exports (in Local Currency Unit) in Cameroon in 2010 to that in 2011?
Your answer should be very brief. 0.88. What is the ratio of the Exports (in Local Currency Unit) in Cuba in 2010 to that in 2011?
Ensure brevity in your answer.  0.84. What is the ratio of the Exports (in Local Currency Unit) of Guinea in 2010 to that in 2011?
Your answer should be very brief. 0.75. What is the ratio of the Exports (in Local Currency Unit) in Afghanistan in 2010 to that in 2012?
Ensure brevity in your answer.  1.25. What is the ratio of the Exports (in Local Currency Unit) in Cameroon in 2010 to that in 2012?
Your answer should be compact. 0.8. What is the ratio of the Exports (in Local Currency Unit) of Cuba in 2010 to that in 2012?
Your answer should be compact. 0.78. What is the ratio of the Exports (in Local Currency Unit) of Guinea in 2010 to that in 2012?
Your answer should be compact. 0.65. What is the ratio of the Exports (in Local Currency Unit) of Afghanistan in 2011 to that in 2012?
Offer a terse response. 0.89. What is the ratio of the Exports (in Local Currency Unit) in Cameroon in 2011 to that in 2012?
Your response must be concise. 0.91. What is the ratio of the Exports (in Local Currency Unit) in Cuba in 2011 to that in 2012?
Provide a succinct answer. 0.93. What is the ratio of the Exports (in Local Currency Unit) of Guinea in 2011 to that in 2012?
Provide a short and direct response. 0.87. What is the difference between the highest and the second highest Exports (in Local Currency Unit) in Afghanistan?
Your answer should be compact. 2.95e+09. What is the difference between the highest and the second highest Exports (in Local Currency Unit) in Cameroon?
Give a very brief answer. 2.00e+1. What is the difference between the highest and the second highest Exports (in Local Currency Unit) of Cuba?
Offer a very short reply. 1.34e+09. What is the difference between the highest and the second highest Exports (in Local Currency Unit) of Guinea?
Your response must be concise. 1.56e+12. What is the difference between the highest and the lowest Exports (in Local Currency Unit) in Afghanistan?
Your answer should be compact. 4.11e+1. What is the difference between the highest and the lowest Exports (in Local Currency Unit) in Cameroon?
Provide a succinct answer. 7.70e+11. What is the difference between the highest and the lowest Exports (in Local Currency Unit) in Cuba?
Give a very brief answer. 7.82e+09. What is the difference between the highest and the lowest Exports (in Local Currency Unit) in Guinea?
Make the answer very short. 6.77e+12. 